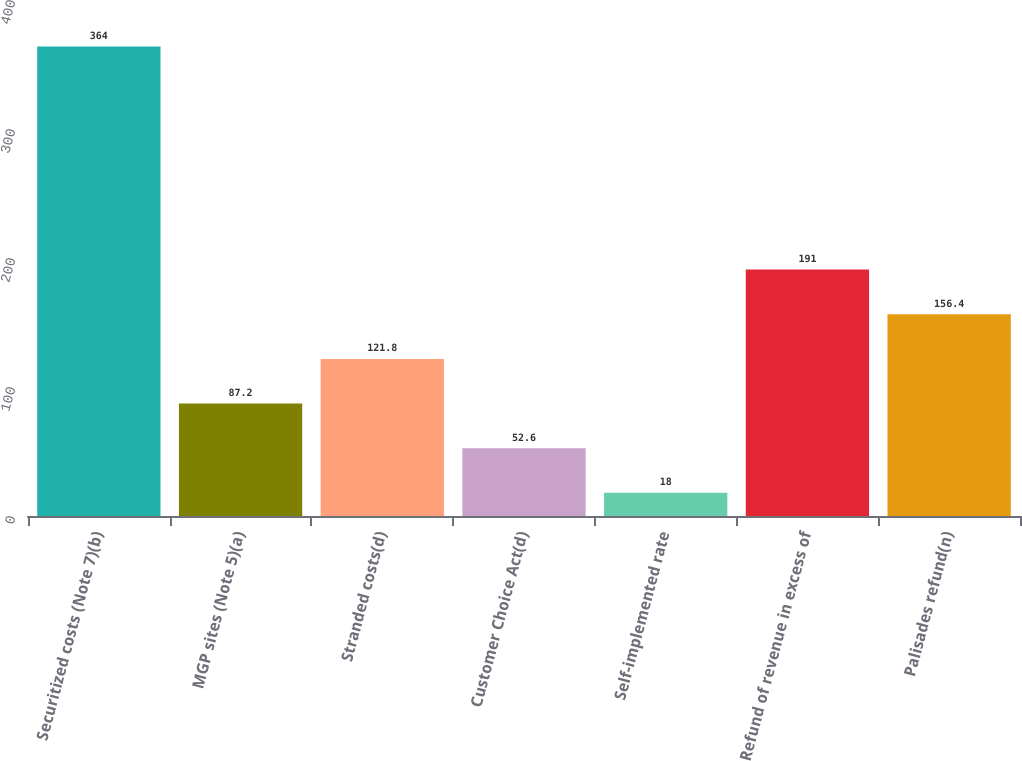<chart> <loc_0><loc_0><loc_500><loc_500><bar_chart><fcel>Securitized costs (Note 7)(b)<fcel>MGP sites (Note 5)(a)<fcel>Stranded costs(d)<fcel>Customer Choice Act(d)<fcel>Self-implemented rate<fcel>Refund of revenue in excess of<fcel>Palisades refund(n)<nl><fcel>364<fcel>87.2<fcel>121.8<fcel>52.6<fcel>18<fcel>191<fcel>156.4<nl></chart> 